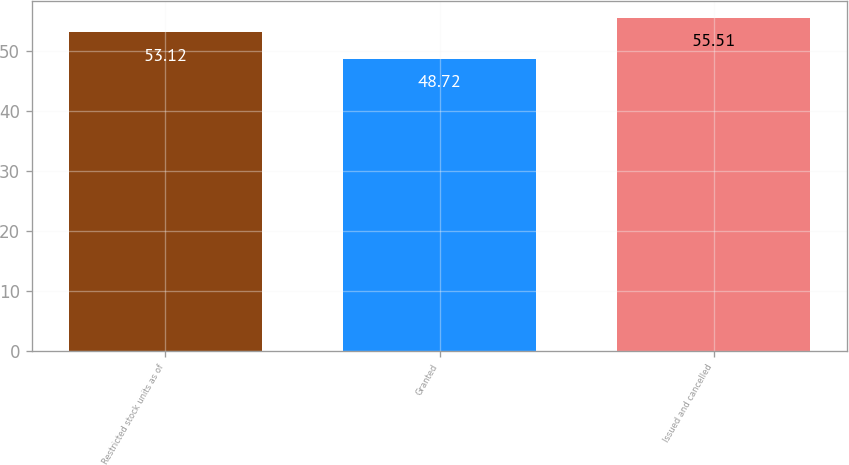<chart> <loc_0><loc_0><loc_500><loc_500><bar_chart><fcel>Restricted stock units as of<fcel>Granted<fcel>Issued and cancelled<nl><fcel>53.12<fcel>48.72<fcel>55.51<nl></chart> 